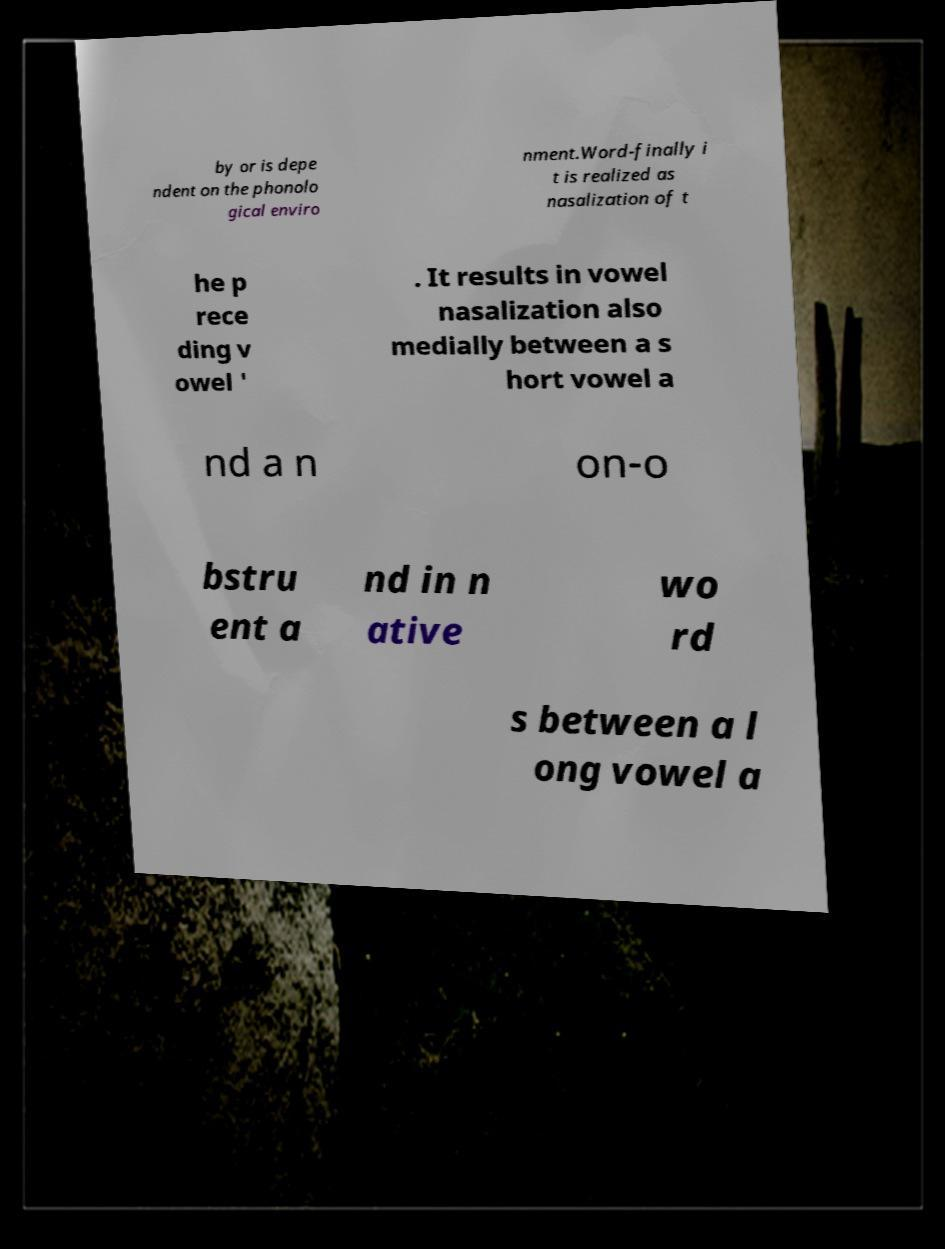For documentation purposes, I need the text within this image transcribed. Could you provide that? by or is depe ndent on the phonolo gical enviro nment.Word-finally i t is realized as nasalization of t he p rece ding v owel ' . It results in vowel nasalization also medially between a s hort vowel a nd a n on-o bstru ent a nd in n ative wo rd s between a l ong vowel a 